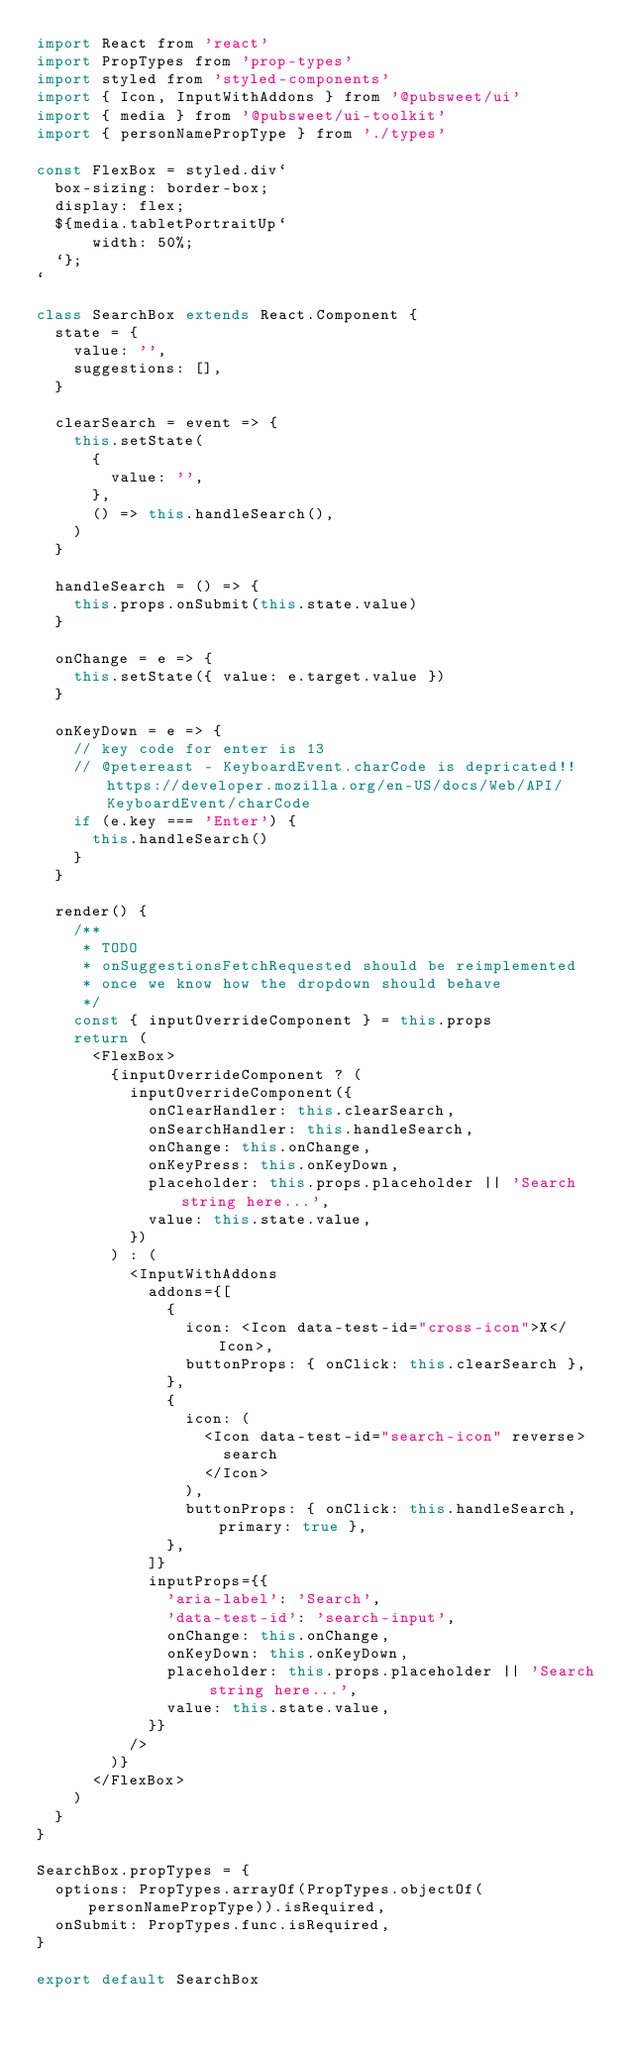<code> <loc_0><loc_0><loc_500><loc_500><_JavaScript_>import React from 'react'
import PropTypes from 'prop-types'
import styled from 'styled-components'
import { Icon, InputWithAddons } from '@pubsweet/ui'
import { media } from '@pubsweet/ui-toolkit'
import { personNamePropType } from './types'

const FlexBox = styled.div`
  box-sizing: border-box;
  display: flex;
  ${media.tabletPortraitUp`
      width: 50%;
  `};
`

class SearchBox extends React.Component {
  state = {
    value: '',
    suggestions: [],
  }

  clearSearch = event => {
    this.setState(
      {
        value: '',
      },
      () => this.handleSearch(),
    )
  }

  handleSearch = () => {
    this.props.onSubmit(this.state.value)
  }

  onChange = e => {
    this.setState({ value: e.target.value })
  }

  onKeyDown = e => {
    // key code for enter is 13
    // @petereast - KeyboardEvent.charCode is depricated!! https://developer.mozilla.org/en-US/docs/Web/API/KeyboardEvent/charCode
    if (e.key === 'Enter') {
      this.handleSearch()
    }
  }

  render() {
    /**
     * TODO
     * onSuggestionsFetchRequested should be reimplemented
     * once we know how the dropdown should behave
     */
    const { inputOverrideComponent } = this.props
    return (
      <FlexBox>
        {inputOverrideComponent ? (
          inputOverrideComponent({
            onClearHandler: this.clearSearch,
            onSearchHandler: this.handleSearch,
            onChange: this.onChange,
            onKeyPress: this.onKeyDown,
            placeholder: this.props.placeholder || 'Search string here...',
            value: this.state.value,
          })
        ) : (
          <InputWithAddons
            addons={[
              {
                icon: <Icon data-test-id="cross-icon">X</Icon>,
                buttonProps: { onClick: this.clearSearch },
              },
              {
                icon: (
                  <Icon data-test-id="search-icon" reverse>
                    search
                  </Icon>
                ),
                buttonProps: { onClick: this.handleSearch, primary: true },
              },
            ]}
            inputProps={{
              'aria-label': 'Search',
              'data-test-id': 'search-input',
              onChange: this.onChange,
              onKeyDown: this.onKeyDown,
              placeholder: this.props.placeholder || 'Search string here...',
              value: this.state.value,
            }}
          />
        )}
      </FlexBox>
    )
  }
}

SearchBox.propTypes = {
  options: PropTypes.arrayOf(PropTypes.objectOf(personNamePropType)).isRequired,
  onSubmit: PropTypes.func.isRequired,
}

export default SearchBox
</code> 